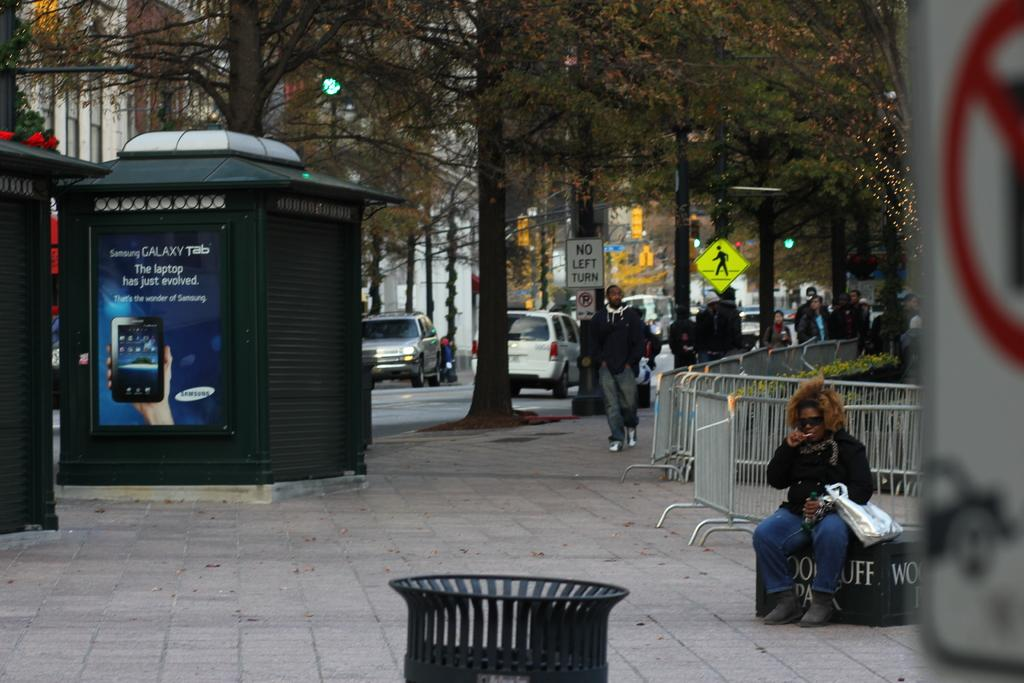<image>
Render a clear and concise summary of the photo. A busy city street with a big sign advertising Galaxy Tab. 